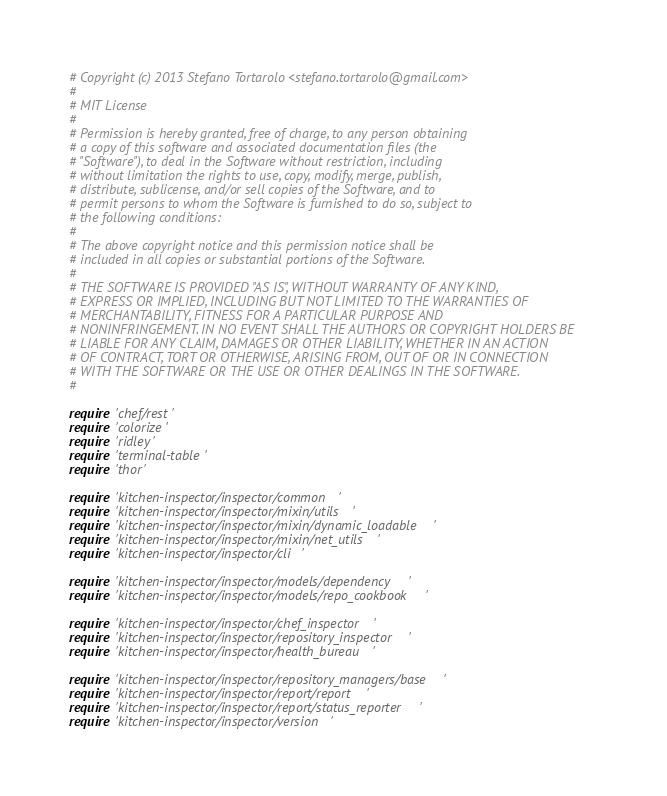Convert code to text. <code><loc_0><loc_0><loc_500><loc_500><_Ruby_># Copyright (c) 2013 Stefano Tortarolo <stefano.tortarolo@gmail.com>
#
# MIT License
#
# Permission is hereby granted, free of charge, to any person obtaining
# a copy of this software and associated documentation files (the
# "Software"), to deal in the Software without restriction, including
# without limitation the rights to use, copy, modify, merge, publish,
# distribute, sublicense, and/or sell copies of the Software, and to
# permit persons to whom the Software is furnished to do so, subject to
# the following conditions:
#
# The above copyright notice and this permission notice shall be
# included in all copies or substantial portions of the Software.
#
# THE SOFTWARE IS PROVIDED "AS IS", WITHOUT WARRANTY OF ANY KIND,
# EXPRESS OR IMPLIED, INCLUDING BUT NOT LIMITED TO THE WARRANTIES OF
# MERCHANTABILITY, FITNESS FOR A PARTICULAR PURPOSE AND
# NONINFRINGEMENT. IN NO EVENT SHALL THE AUTHORS OR COPYRIGHT HOLDERS BE
# LIABLE FOR ANY CLAIM, DAMAGES OR OTHER LIABILITY, WHETHER IN AN ACTION
# OF CONTRACT, TORT OR OTHERWISE, ARISING FROM, OUT OF OR IN CONNECTION
# WITH THE SOFTWARE OR THE USE OR OTHER DEALINGS IN THE SOFTWARE.
#

require 'chef/rest'
require 'colorize'
require 'ridley'
require 'terminal-table'
require 'thor'

require 'kitchen-inspector/inspector/common'
require 'kitchen-inspector/inspector/mixin/utils'
require 'kitchen-inspector/inspector/mixin/dynamic_loadable'
require 'kitchen-inspector/inspector/mixin/net_utils'
require 'kitchen-inspector/inspector/cli'

require 'kitchen-inspector/inspector/models/dependency'
require 'kitchen-inspector/inspector/models/repo_cookbook'

require 'kitchen-inspector/inspector/chef_inspector'
require 'kitchen-inspector/inspector/repository_inspector'
require 'kitchen-inspector/inspector/health_bureau'

require 'kitchen-inspector/inspector/repository_managers/base'
require 'kitchen-inspector/inspector/report/report'
require 'kitchen-inspector/inspector/report/status_reporter'
require 'kitchen-inspector/inspector/version'
</code> 